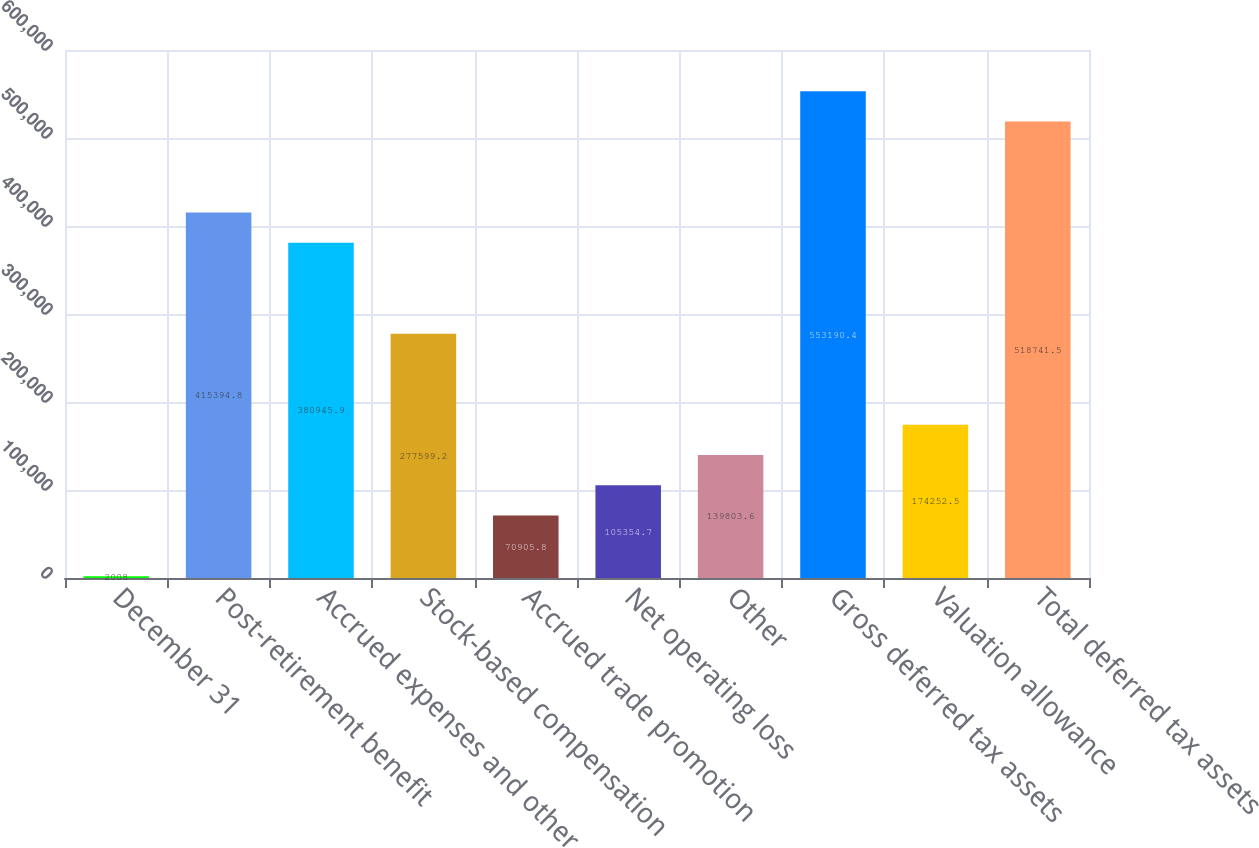Convert chart to OTSL. <chart><loc_0><loc_0><loc_500><loc_500><bar_chart><fcel>December 31<fcel>Post-retirement benefit<fcel>Accrued expenses and other<fcel>Stock-based compensation<fcel>Accrued trade promotion<fcel>Net operating loss<fcel>Other<fcel>Gross deferred tax assets<fcel>Valuation allowance<fcel>Total deferred tax assets<nl><fcel>2008<fcel>415395<fcel>380946<fcel>277599<fcel>70905.8<fcel>105355<fcel>139804<fcel>553190<fcel>174252<fcel>518742<nl></chart> 